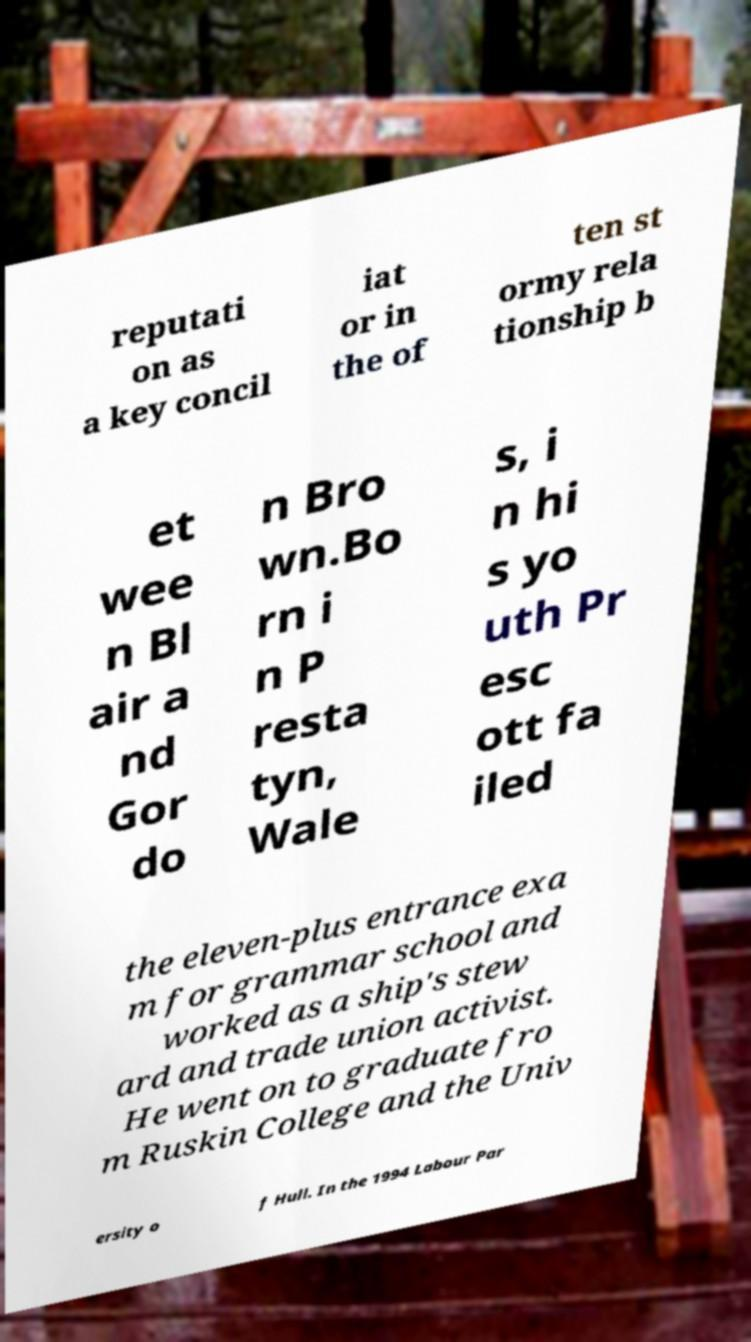For documentation purposes, I need the text within this image transcribed. Could you provide that? reputati on as a key concil iat or in the of ten st ormy rela tionship b et wee n Bl air a nd Gor do n Bro wn.Bo rn i n P resta tyn, Wale s, i n hi s yo uth Pr esc ott fa iled the eleven-plus entrance exa m for grammar school and worked as a ship's stew ard and trade union activist. He went on to graduate fro m Ruskin College and the Univ ersity o f Hull. In the 1994 Labour Par 